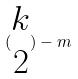<formula> <loc_0><loc_0><loc_500><loc_500>( \begin{matrix} k \\ 2 \end{matrix} ) - m</formula> 